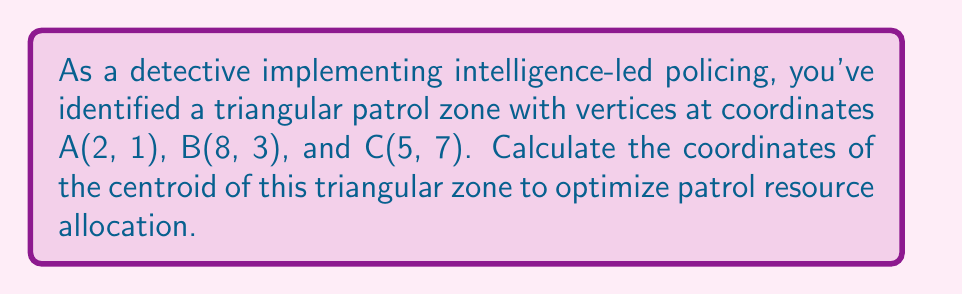Could you help me with this problem? To find the centroid of a triangle, we need to follow these steps:

1) The centroid of a triangle is located at the intersection of its medians. It divides each median in a 2:1 ratio, with the longer segment closer to the vertex.

2) The coordinates of the centroid (x, y) can be calculated using the following formulas:

   $$x = \frac{x_1 + x_2 + x_3}{3}$$
   $$y = \frac{y_1 + y_2 + y_3}{3}$$

   Where $(x_1, y_1)$, $(x_2, y_2)$, and $(x_3, y_3)$ are the coordinates of the three vertices.

3) Given vertices:
   A(2, 1), B(8, 3), C(5, 7)

4) Substituting into the formulas:

   $$x = \frac{2 + 8 + 5}{3} = \frac{15}{3} = 5$$

   $$y = \frac{1 + 3 + 7}{3} = \frac{11}{3} \approx 3.67$$

5) Therefore, the coordinates of the centroid are (5, 11/3).

[asy]
unitsize(1cm);
pair A = (2,1);
pair B = (8,3);
pair C = (5,7);
pair G = (5,11/3);

draw(A--B--C--cycle);
dot(A); dot(B); dot(C); dot(G);

label("A(2,1)", A, SW);
label("B(8,3)", B, SE);
label("C(5,7)", C, N);
label("G(5,11/3)", G, E);
[/asy]
Answer: (5, 11/3) 